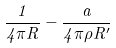Convert formula to latex. <formula><loc_0><loc_0><loc_500><loc_500>\frac { 1 } { 4 \pi R } - \frac { a } { 4 \pi \rho R ^ { \prime } }</formula> 